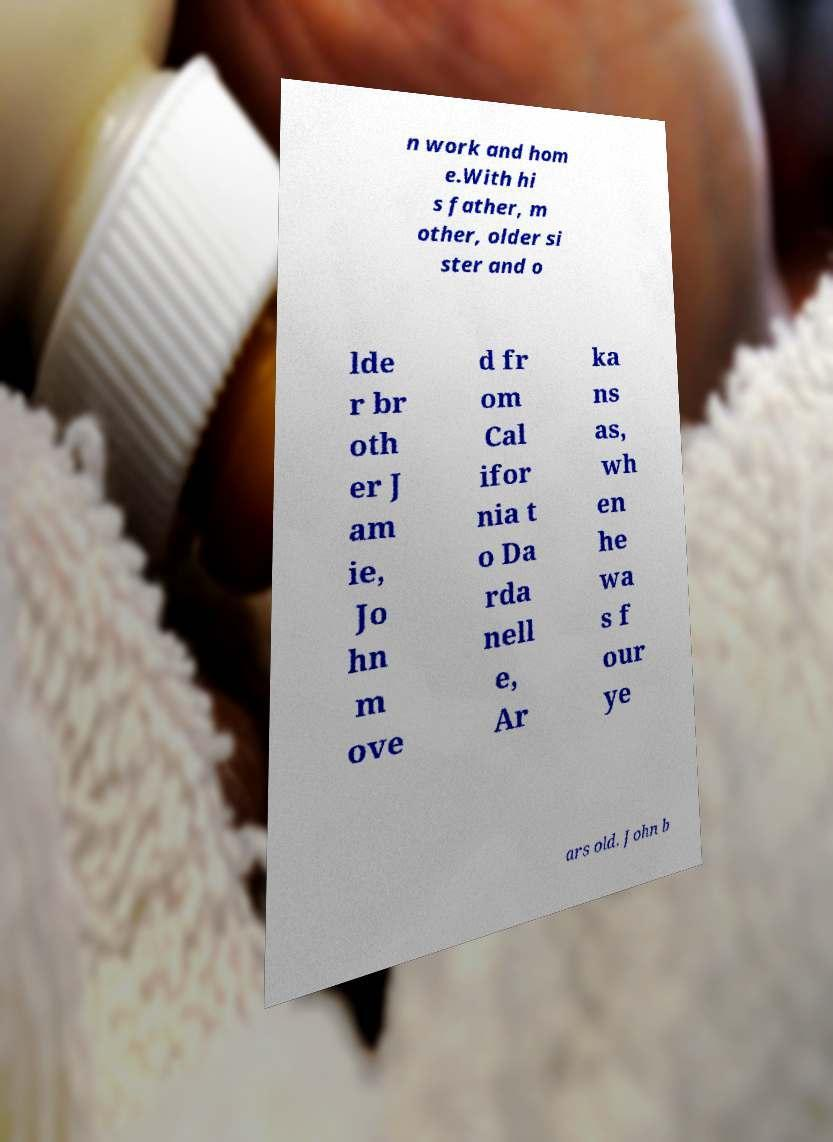Could you assist in decoding the text presented in this image and type it out clearly? n work and hom e.With hi s father, m other, older si ster and o lde r br oth er J am ie, Jo hn m ove d fr om Cal ifor nia t o Da rda nell e, Ar ka ns as, wh en he wa s f our ye ars old. John b 